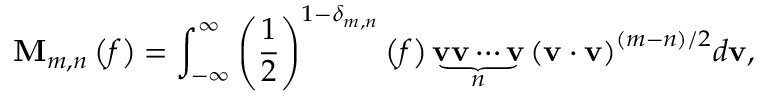<formula> <loc_0><loc_0><loc_500><loc_500>{ M } _ { m , n } \left ( f \right ) = \int _ { - \infty } ^ { \infty } { { { \left ( { \frac { 1 } { 2 } } \right ) } ^ { 1 - { \delta _ { m , n } } } } \left ( f \right ) \underbrace { { v } { v } \cdots { v } } _ { n } { { \left ( { { v } \cdot { v } } \right ) } ^ { \left ( { m - n } \right ) / 2 } } d { v } } ,</formula> 